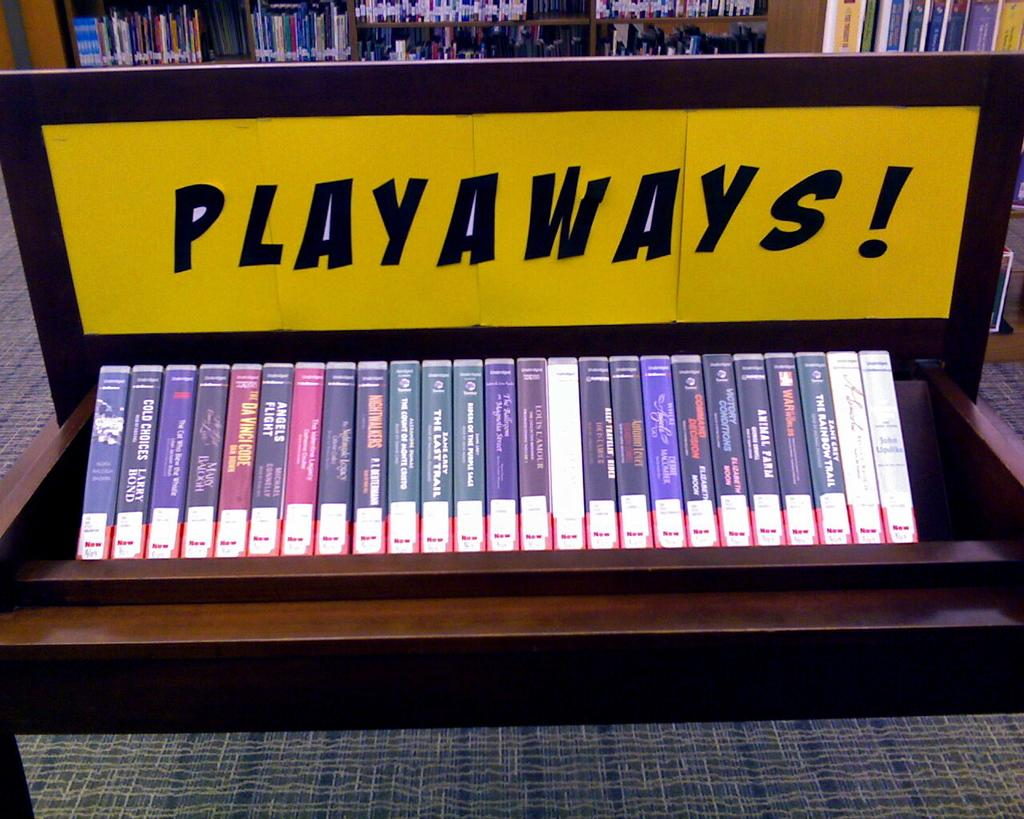<image>
Write a terse but informative summary of the picture. A row of VHS movies are on a table that says Playaways. 